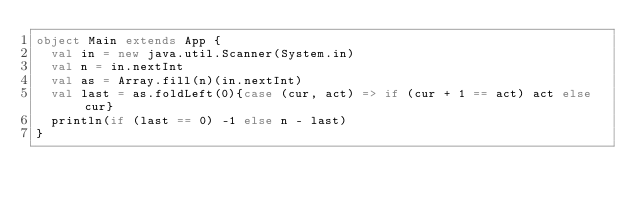<code> <loc_0><loc_0><loc_500><loc_500><_Scala_>object Main extends App {
  val in = new java.util.Scanner(System.in)
  val n = in.nextInt
  val as = Array.fill(n)(in.nextInt)
  val last = as.foldLeft(0){case (cur, act) => if (cur + 1 == act) act else cur}
  println(if (last == 0) -1 else n - last)
}</code> 